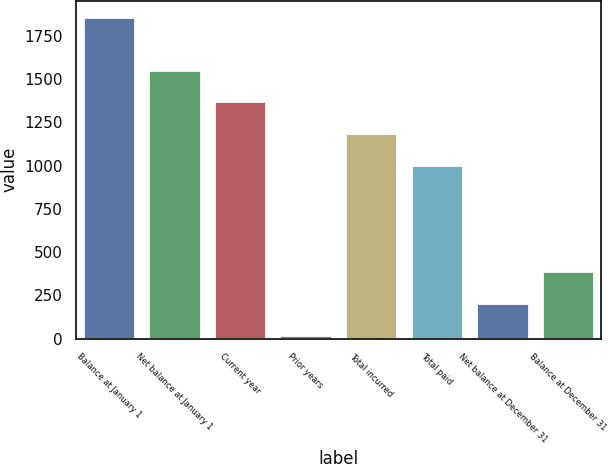Convert chart. <chart><loc_0><loc_0><loc_500><loc_500><bar_chart><fcel>Balance at January 1<fcel>Net balance at January 1<fcel>Current year<fcel>Prior years<fcel>Total incurred<fcel>Total paid<fcel>Net balance at December 31<fcel>Balance at December 31<nl><fcel>1861<fcel>1554.7<fcel>1370.8<fcel>22<fcel>1186.9<fcel>1003<fcel>205.9<fcel>389.8<nl></chart> 